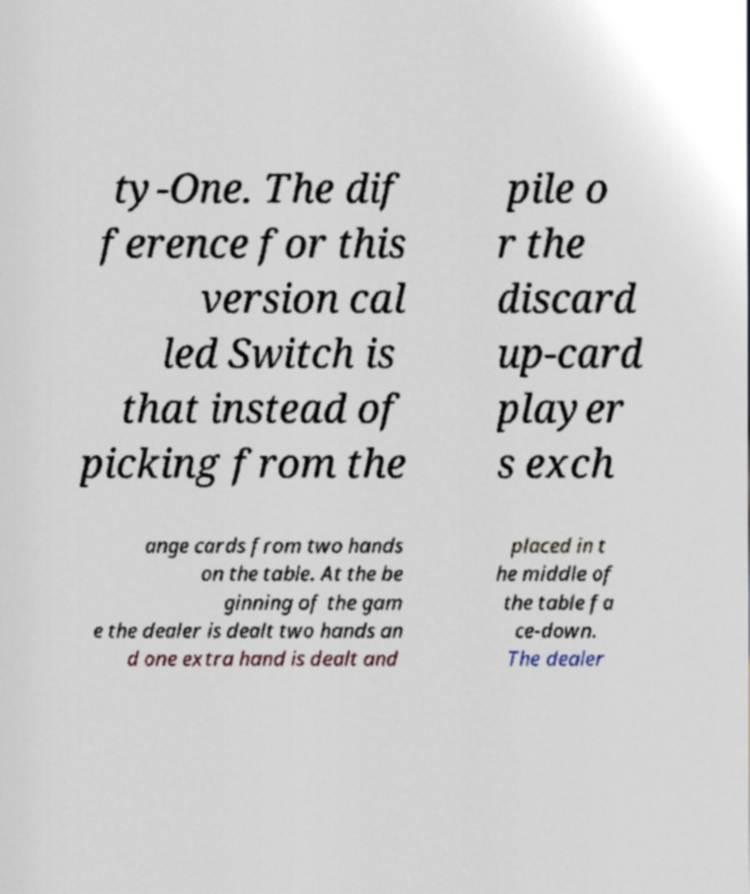What messages or text are displayed in this image? I need them in a readable, typed format. ty-One. The dif ference for this version cal led Switch is that instead of picking from the pile o r the discard up-card player s exch ange cards from two hands on the table. At the be ginning of the gam e the dealer is dealt two hands an d one extra hand is dealt and placed in t he middle of the table fa ce-down. The dealer 